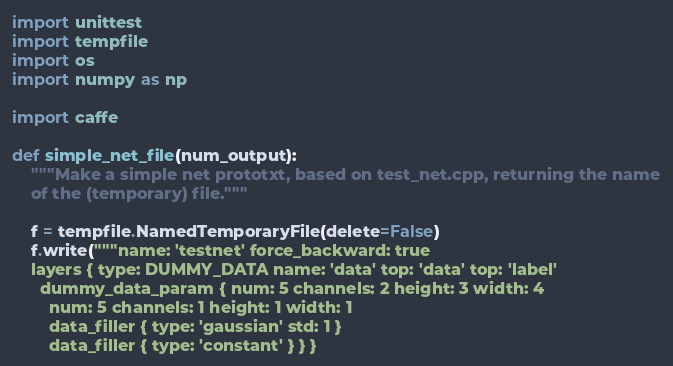<code> <loc_0><loc_0><loc_500><loc_500><_Python_>import unittest
import tempfile
import os
import numpy as np

import caffe

def simple_net_file(num_output):
    """Make a simple net prototxt, based on test_net.cpp, returning the name
    of the (temporary) file."""

    f = tempfile.NamedTemporaryFile(delete=False)
    f.write("""name: 'testnet' force_backward: true
    layers { type: DUMMY_DATA name: 'data' top: 'data' top: 'label'
      dummy_data_param { num: 5 channels: 2 height: 3 width: 4
        num: 5 channels: 1 height: 1 width: 1
        data_filler { type: 'gaussian' std: 1 }
        data_filler { type: 'constant' } } }</code> 